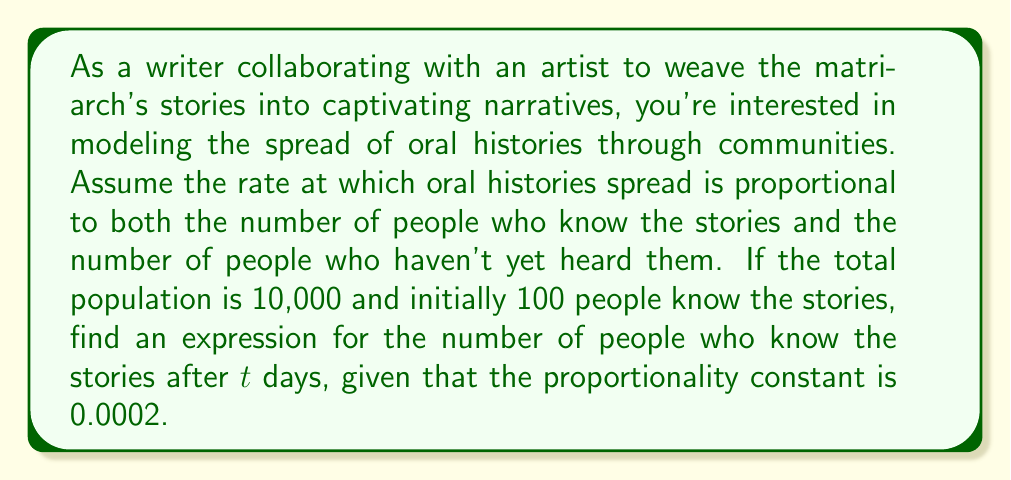Could you help me with this problem? Let's approach this step-by-step:

1) Let $P(t)$ be the number of people who know the stories at time $t$.

2) The total population is 10,000, so 10,000 - $P(t)$ represents the number of people who don't know the stories.

3) The rate of change is proportional to $P(t)$ and $(10000 - P(t))$, with proportionality constant 0.0002. This gives us the differential equation:

   $$\frac{dP}{dt} = 0.0002P(10000 - P)$$

4) This is a separable differential equation. Let's separate the variables:

   $$\frac{dP}{P(10000 - P)} = 0.0002dt$$

5) Integrating both sides:

   $$\int \frac{dP}{P(10000 - P)} = \int 0.0002dt$$

6) The left side can be integrated using partial fractions:

   $$\frac{1}{10000}\ln|\frac{P}{10000-P}| = 0.0002t + C$$

7) Now, let's use the initial condition. At $t=0$, $P(0) = 100$:

   $$\frac{1}{10000}\ln|\frac{100}{9900}| = C$$

8) Subtracting this from the general solution:

   $$\frac{1}{10000}\ln|\frac{P}{10000-P}| - \frac{1}{10000}\ln|\frac{100}{9900}| = 0.0002t$$

9) Simplifying:

   $$\ln|\frac{P}{10000-P}| - \ln|\frac{100}{9900}| = 2t$$

10) Taking $e$ to the power of both sides:

    $$\frac{P}{10000-P} = \frac{100}{9900}e^{2t}$$

11) Solving for $P$:

    $$P = \frac{1000000e^{2t}}{99+e^{2t}}$$

This is the expression for the number of people who know the stories after $t$ days.
Answer: $P(t) = \frac{1000000e^{2t}}{99+e^{2t}}$ 